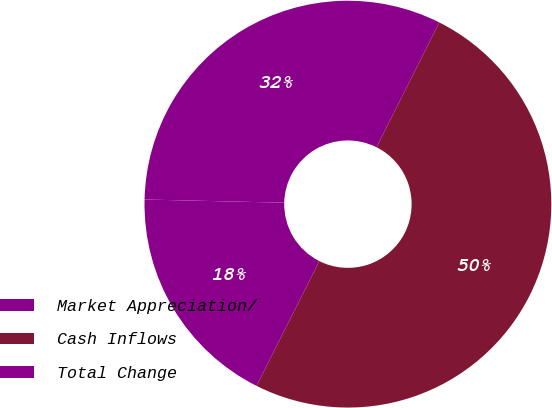Convert chart to OTSL. <chart><loc_0><loc_0><loc_500><loc_500><pie_chart><fcel>Market Appreciation/<fcel>Cash Inflows<fcel>Total Change<nl><fcel>32.05%<fcel>50.0%<fcel>17.95%<nl></chart> 